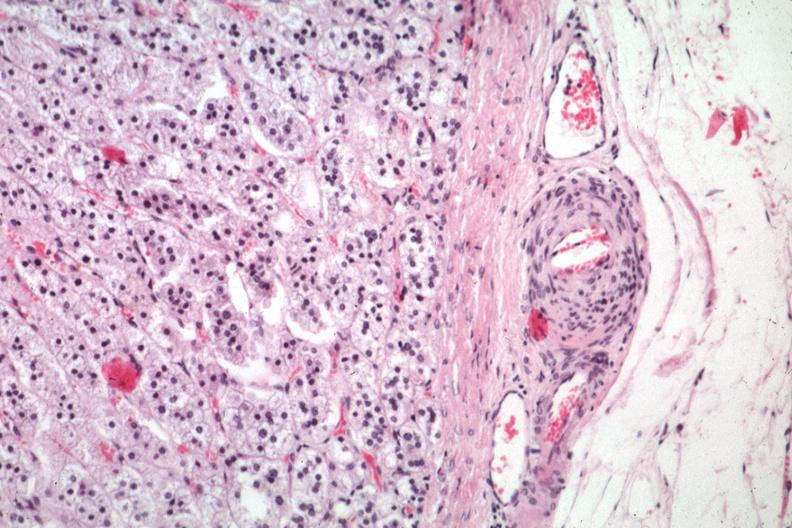s atheromatous embolus present?
Answer the question using a single word or phrase. Yes 